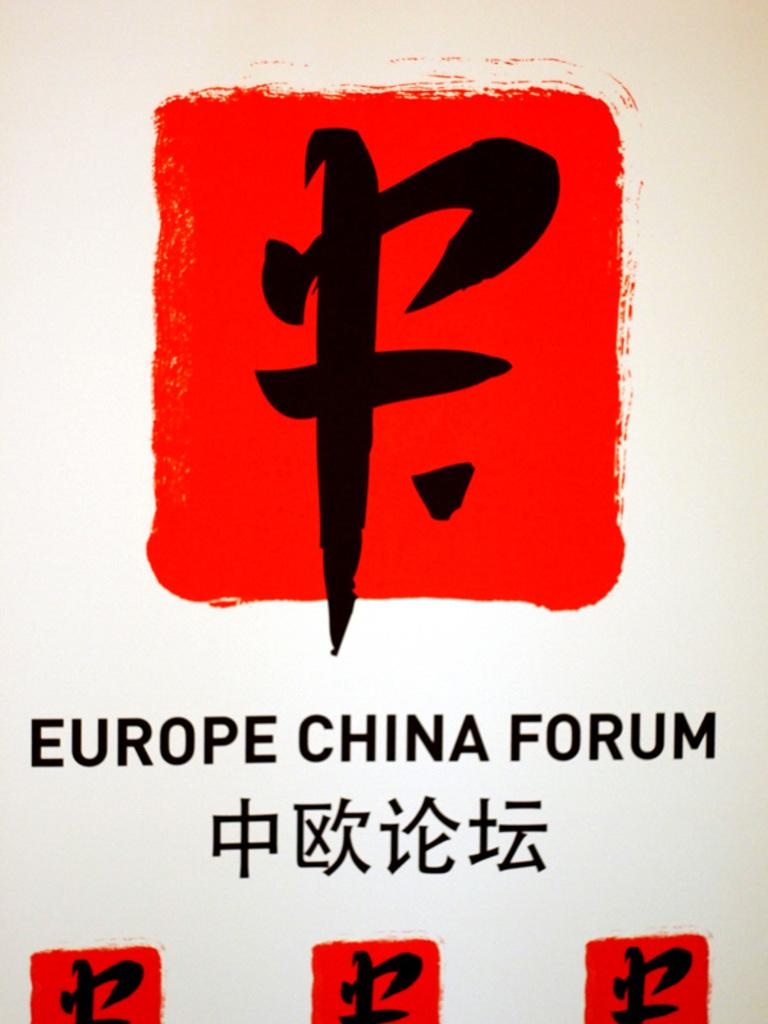<image>
Render a clear and concise summary of the photo. a red symbol with the word Europe on it 